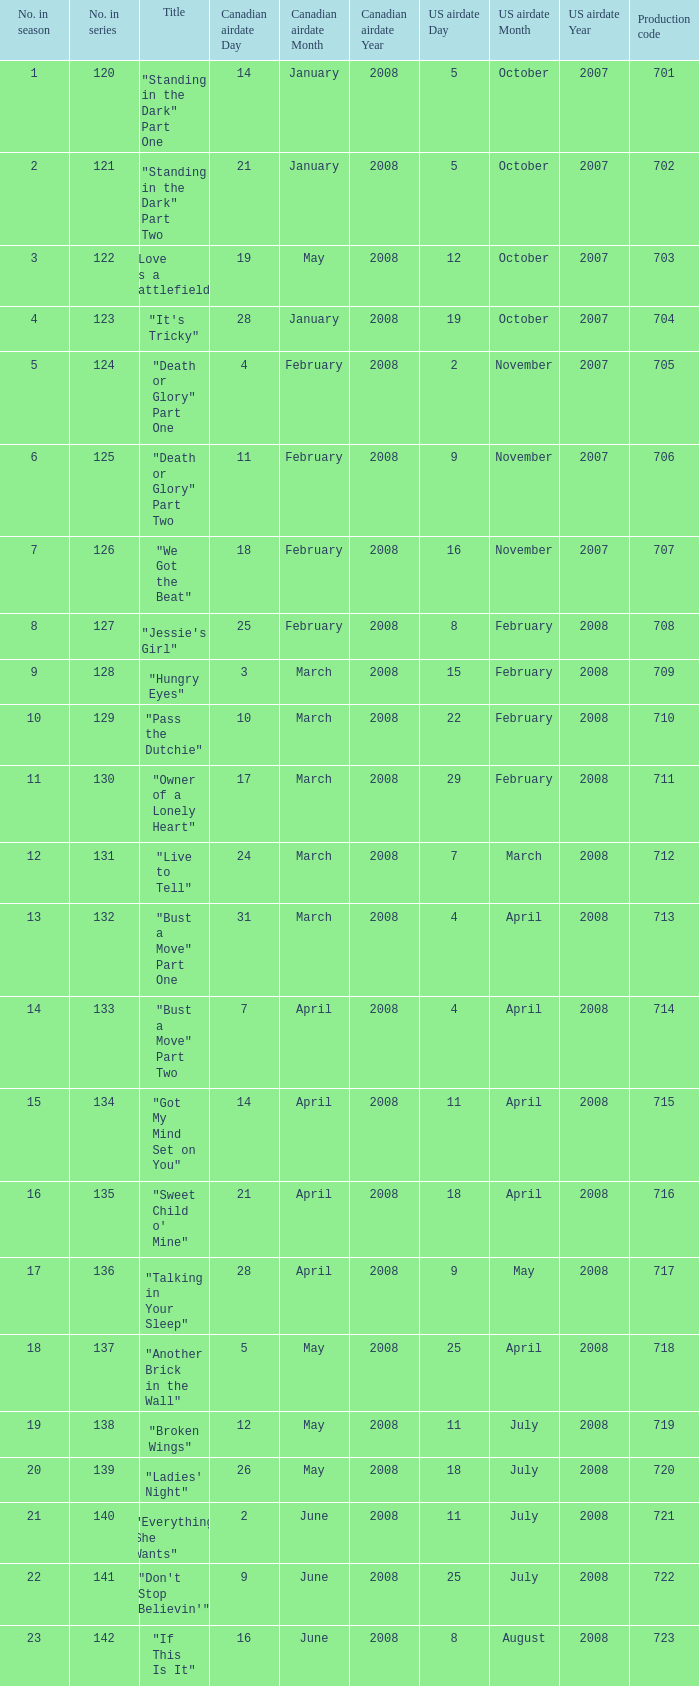The U.S. airdate of 8 august 2008 also had canadian airdates of what? 16 June 2008. 